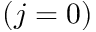Convert formula to latex. <formula><loc_0><loc_0><loc_500><loc_500>( j = 0 )</formula> 